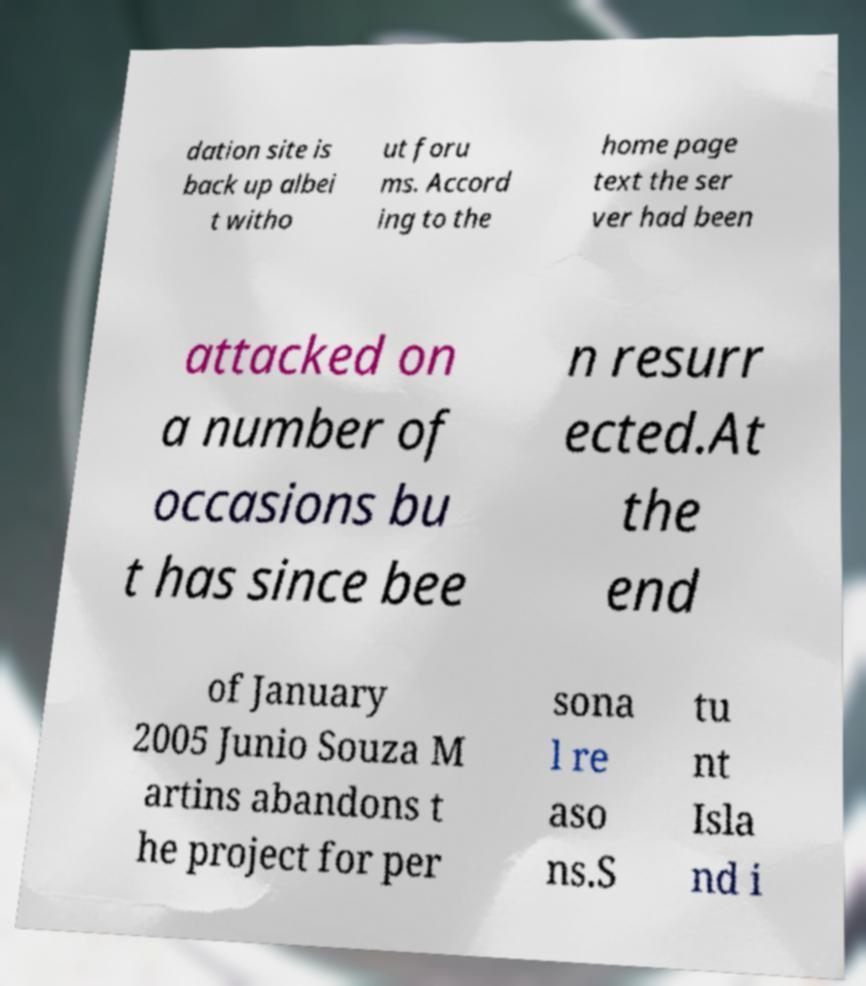Can you accurately transcribe the text from the provided image for me? dation site is back up albei t witho ut foru ms. Accord ing to the home page text the ser ver had been attacked on a number of occasions bu t has since bee n resurr ected.At the end of January 2005 Junio Souza M artins abandons t he project for per sona l re aso ns.S tu nt Isla nd i 